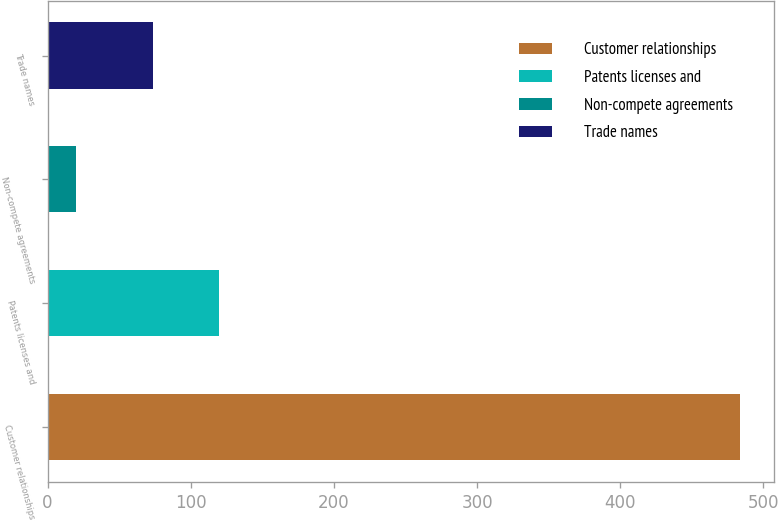Convert chart to OTSL. <chart><loc_0><loc_0><loc_500><loc_500><bar_chart><fcel>Customer relationships<fcel>Patents licenses and<fcel>Non-compete agreements<fcel>Trade names<nl><fcel>483.3<fcel>119.77<fcel>19.6<fcel>73.4<nl></chart> 